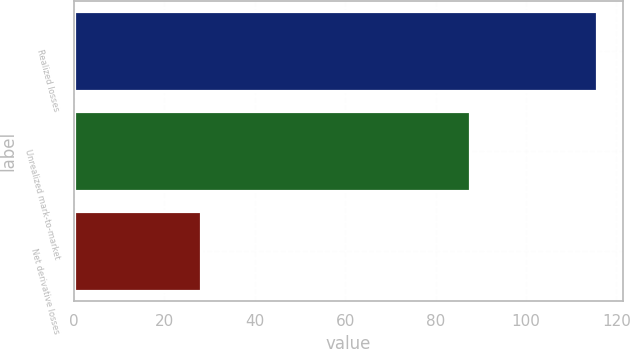Convert chart. <chart><loc_0><loc_0><loc_500><loc_500><bar_chart><fcel>Realized losses<fcel>Unrealized mark-to-market<fcel>Net derivative losses<nl><fcel>115.6<fcel>87.5<fcel>28.1<nl></chart> 